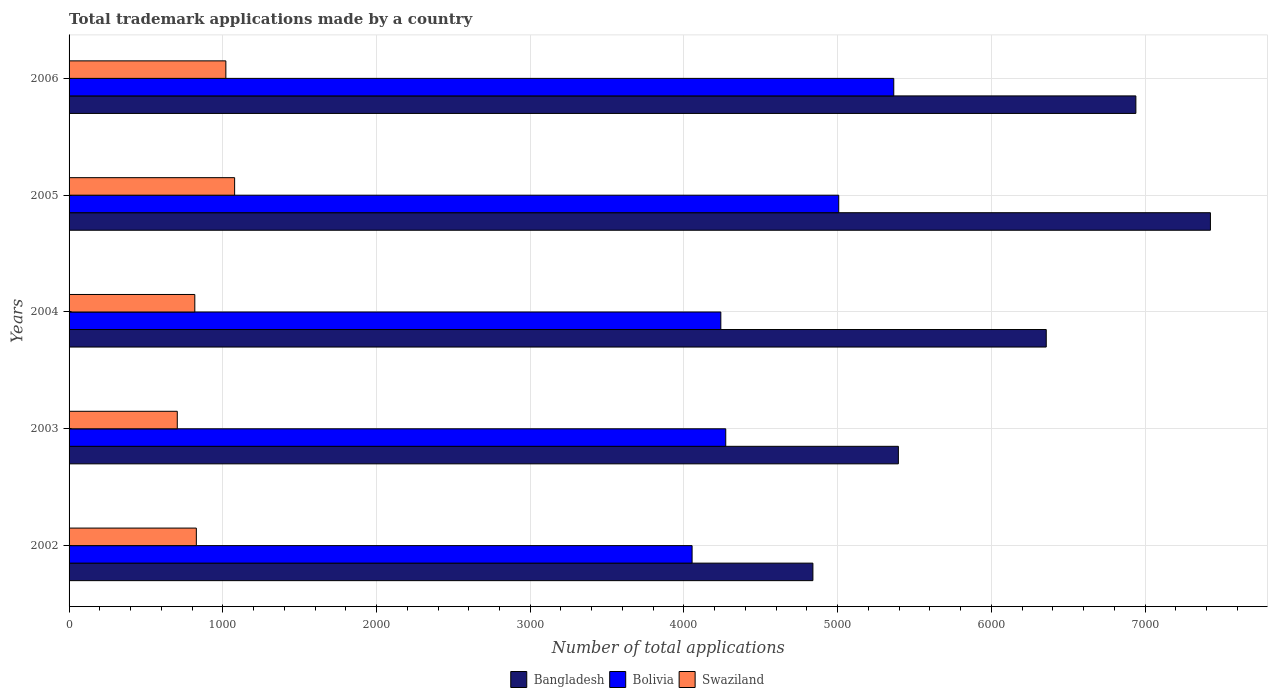How many groups of bars are there?
Keep it short and to the point. 5. Are the number of bars per tick equal to the number of legend labels?
Your answer should be very brief. Yes. Are the number of bars on each tick of the Y-axis equal?
Provide a short and direct response. Yes. How many bars are there on the 2nd tick from the top?
Provide a succinct answer. 3. What is the label of the 3rd group of bars from the top?
Keep it short and to the point. 2004. What is the number of applications made by in Bolivia in 2002?
Make the answer very short. 4053. Across all years, what is the maximum number of applications made by in Swaziland?
Your answer should be compact. 1077. Across all years, what is the minimum number of applications made by in Swaziland?
Keep it short and to the point. 704. What is the total number of applications made by in Swaziland in the graph?
Offer a terse response. 4447. What is the difference between the number of applications made by in Bolivia in 2004 and that in 2006?
Make the answer very short. -1125. What is the difference between the number of applications made by in Bangladesh in 2004 and the number of applications made by in Bolivia in 2005?
Ensure brevity in your answer.  1350. What is the average number of applications made by in Swaziland per year?
Offer a very short reply. 889.4. In the year 2002, what is the difference between the number of applications made by in Bangladesh and number of applications made by in Bolivia?
Your answer should be very brief. 786. What is the ratio of the number of applications made by in Bangladesh in 2003 to that in 2005?
Ensure brevity in your answer.  0.73. What is the difference between the highest and the second highest number of applications made by in Bolivia?
Ensure brevity in your answer.  358. What is the difference between the highest and the lowest number of applications made by in Bangladesh?
Your response must be concise. 2586. In how many years, is the number of applications made by in Swaziland greater than the average number of applications made by in Swaziland taken over all years?
Provide a succinct answer. 2. Is the sum of the number of applications made by in Bolivia in 2002 and 2006 greater than the maximum number of applications made by in Bangladesh across all years?
Your response must be concise. Yes. How many bars are there?
Your answer should be very brief. 15. What is the difference between two consecutive major ticks on the X-axis?
Your answer should be very brief. 1000. Are the values on the major ticks of X-axis written in scientific E-notation?
Your response must be concise. No. How many legend labels are there?
Make the answer very short. 3. How are the legend labels stacked?
Offer a very short reply. Horizontal. What is the title of the graph?
Provide a short and direct response. Total trademark applications made by a country. What is the label or title of the X-axis?
Give a very brief answer. Number of total applications. What is the Number of total applications of Bangladesh in 2002?
Make the answer very short. 4839. What is the Number of total applications of Bolivia in 2002?
Keep it short and to the point. 4053. What is the Number of total applications in Swaziland in 2002?
Your answer should be very brief. 828. What is the Number of total applications in Bangladesh in 2003?
Make the answer very short. 5395. What is the Number of total applications of Bolivia in 2003?
Give a very brief answer. 4272. What is the Number of total applications of Swaziland in 2003?
Your answer should be compact. 704. What is the Number of total applications in Bangladesh in 2004?
Ensure brevity in your answer.  6357. What is the Number of total applications in Bolivia in 2004?
Your answer should be very brief. 4240. What is the Number of total applications of Swaziland in 2004?
Your response must be concise. 818. What is the Number of total applications in Bangladesh in 2005?
Give a very brief answer. 7425. What is the Number of total applications of Bolivia in 2005?
Your answer should be very brief. 5007. What is the Number of total applications of Swaziland in 2005?
Your answer should be compact. 1077. What is the Number of total applications of Bangladesh in 2006?
Give a very brief answer. 6940. What is the Number of total applications in Bolivia in 2006?
Your answer should be very brief. 5365. What is the Number of total applications of Swaziland in 2006?
Provide a succinct answer. 1020. Across all years, what is the maximum Number of total applications of Bangladesh?
Offer a very short reply. 7425. Across all years, what is the maximum Number of total applications in Bolivia?
Offer a terse response. 5365. Across all years, what is the maximum Number of total applications in Swaziland?
Your answer should be compact. 1077. Across all years, what is the minimum Number of total applications of Bangladesh?
Ensure brevity in your answer.  4839. Across all years, what is the minimum Number of total applications of Bolivia?
Your answer should be very brief. 4053. Across all years, what is the minimum Number of total applications in Swaziland?
Ensure brevity in your answer.  704. What is the total Number of total applications in Bangladesh in the graph?
Keep it short and to the point. 3.10e+04. What is the total Number of total applications in Bolivia in the graph?
Offer a very short reply. 2.29e+04. What is the total Number of total applications of Swaziland in the graph?
Offer a terse response. 4447. What is the difference between the Number of total applications of Bangladesh in 2002 and that in 2003?
Make the answer very short. -556. What is the difference between the Number of total applications in Bolivia in 2002 and that in 2003?
Ensure brevity in your answer.  -219. What is the difference between the Number of total applications of Swaziland in 2002 and that in 2003?
Offer a very short reply. 124. What is the difference between the Number of total applications of Bangladesh in 2002 and that in 2004?
Your answer should be compact. -1518. What is the difference between the Number of total applications in Bolivia in 2002 and that in 2004?
Make the answer very short. -187. What is the difference between the Number of total applications of Swaziland in 2002 and that in 2004?
Keep it short and to the point. 10. What is the difference between the Number of total applications of Bangladesh in 2002 and that in 2005?
Ensure brevity in your answer.  -2586. What is the difference between the Number of total applications in Bolivia in 2002 and that in 2005?
Your answer should be compact. -954. What is the difference between the Number of total applications in Swaziland in 2002 and that in 2005?
Give a very brief answer. -249. What is the difference between the Number of total applications in Bangladesh in 2002 and that in 2006?
Ensure brevity in your answer.  -2101. What is the difference between the Number of total applications of Bolivia in 2002 and that in 2006?
Ensure brevity in your answer.  -1312. What is the difference between the Number of total applications in Swaziland in 2002 and that in 2006?
Ensure brevity in your answer.  -192. What is the difference between the Number of total applications of Bangladesh in 2003 and that in 2004?
Offer a terse response. -962. What is the difference between the Number of total applications in Swaziland in 2003 and that in 2004?
Your answer should be very brief. -114. What is the difference between the Number of total applications in Bangladesh in 2003 and that in 2005?
Make the answer very short. -2030. What is the difference between the Number of total applications in Bolivia in 2003 and that in 2005?
Provide a succinct answer. -735. What is the difference between the Number of total applications in Swaziland in 2003 and that in 2005?
Offer a terse response. -373. What is the difference between the Number of total applications in Bangladesh in 2003 and that in 2006?
Your answer should be compact. -1545. What is the difference between the Number of total applications of Bolivia in 2003 and that in 2006?
Your answer should be very brief. -1093. What is the difference between the Number of total applications of Swaziland in 2003 and that in 2006?
Your response must be concise. -316. What is the difference between the Number of total applications in Bangladesh in 2004 and that in 2005?
Keep it short and to the point. -1068. What is the difference between the Number of total applications in Bolivia in 2004 and that in 2005?
Offer a very short reply. -767. What is the difference between the Number of total applications of Swaziland in 2004 and that in 2005?
Provide a succinct answer. -259. What is the difference between the Number of total applications in Bangladesh in 2004 and that in 2006?
Your answer should be very brief. -583. What is the difference between the Number of total applications of Bolivia in 2004 and that in 2006?
Offer a very short reply. -1125. What is the difference between the Number of total applications of Swaziland in 2004 and that in 2006?
Your answer should be compact. -202. What is the difference between the Number of total applications in Bangladesh in 2005 and that in 2006?
Your answer should be very brief. 485. What is the difference between the Number of total applications in Bolivia in 2005 and that in 2006?
Provide a short and direct response. -358. What is the difference between the Number of total applications of Swaziland in 2005 and that in 2006?
Provide a short and direct response. 57. What is the difference between the Number of total applications in Bangladesh in 2002 and the Number of total applications in Bolivia in 2003?
Your answer should be very brief. 567. What is the difference between the Number of total applications of Bangladesh in 2002 and the Number of total applications of Swaziland in 2003?
Offer a very short reply. 4135. What is the difference between the Number of total applications in Bolivia in 2002 and the Number of total applications in Swaziland in 2003?
Make the answer very short. 3349. What is the difference between the Number of total applications in Bangladesh in 2002 and the Number of total applications in Bolivia in 2004?
Keep it short and to the point. 599. What is the difference between the Number of total applications in Bangladesh in 2002 and the Number of total applications in Swaziland in 2004?
Your answer should be compact. 4021. What is the difference between the Number of total applications of Bolivia in 2002 and the Number of total applications of Swaziland in 2004?
Give a very brief answer. 3235. What is the difference between the Number of total applications of Bangladesh in 2002 and the Number of total applications of Bolivia in 2005?
Your response must be concise. -168. What is the difference between the Number of total applications of Bangladesh in 2002 and the Number of total applications of Swaziland in 2005?
Make the answer very short. 3762. What is the difference between the Number of total applications in Bolivia in 2002 and the Number of total applications in Swaziland in 2005?
Provide a short and direct response. 2976. What is the difference between the Number of total applications in Bangladesh in 2002 and the Number of total applications in Bolivia in 2006?
Keep it short and to the point. -526. What is the difference between the Number of total applications of Bangladesh in 2002 and the Number of total applications of Swaziland in 2006?
Provide a succinct answer. 3819. What is the difference between the Number of total applications of Bolivia in 2002 and the Number of total applications of Swaziland in 2006?
Provide a succinct answer. 3033. What is the difference between the Number of total applications in Bangladesh in 2003 and the Number of total applications in Bolivia in 2004?
Make the answer very short. 1155. What is the difference between the Number of total applications in Bangladesh in 2003 and the Number of total applications in Swaziland in 2004?
Your response must be concise. 4577. What is the difference between the Number of total applications in Bolivia in 2003 and the Number of total applications in Swaziland in 2004?
Give a very brief answer. 3454. What is the difference between the Number of total applications of Bangladesh in 2003 and the Number of total applications of Bolivia in 2005?
Ensure brevity in your answer.  388. What is the difference between the Number of total applications in Bangladesh in 2003 and the Number of total applications in Swaziland in 2005?
Make the answer very short. 4318. What is the difference between the Number of total applications of Bolivia in 2003 and the Number of total applications of Swaziland in 2005?
Provide a short and direct response. 3195. What is the difference between the Number of total applications of Bangladesh in 2003 and the Number of total applications of Swaziland in 2006?
Your answer should be very brief. 4375. What is the difference between the Number of total applications of Bolivia in 2003 and the Number of total applications of Swaziland in 2006?
Your response must be concise. 3252. What is the difference between the Number of total applications in Bangladesh in 2004 and the Number of total applications in Bolivia in 2005?
Your response must be concise. 1350. What is the difference between the Number of total applications in Bangladesh in 2004 and the Number of total applications in Swaziland in 2005?
Provide a short and direct response. 5280. What is the difference between the Number of total applications in Bolivia in 2004 and the Number of total applications in Swaziland in 2005?
Keep it short and to the point. 3163. What is the difference between the Number of total applications in Bangladesh in 2004 and the Number of total applications in Bolivia in 2006?
Your answer should be very brief. 992. What is the difference between the Number of total applications in Bangladesh in 2004 and the Number of total applications in Swaziland in 2006?
Offer a terse response. 5337. What is the difference between the Number of total applications of Bolivia in 2004 and the Number of total applications of Swaziland in 2006?
Provide a succinct answer. 3220. What is the difference between the Number of total applications of Bangladesh in 2005 and the Number of total applications of Bolivia in 2006?
Make the answer very short. 2060. What is the difference between the Number of total applications in Bangladesh in 2005 and the Number of total applications in Swaziland in 2006?
Your answer should be very brief. 6405. What is the difference between the Number of total applications in Bolivia in 2005 and the Number of total applications in Swaziland in 2006?
Your answer should be compact. 3987. What is the average Number of total applications of Bangladesh per year?
Make the answer very short. 6191.2. What is the average Number of total applications of Bolivia per year?
Provide a succinct answer. 4587.4. What is the average Number of total applications in Swaziland per year?
Keep it short and to the point. 889.4. In the year 2002, what is the difference between the Number of total applications in Bangladesh and Number of total applications in Bolivia?
Ensure brevity in your answer.  786. In the year 2002, what is the difference between the Number of total applications in Bangladesh and Number of total applications in Swaziland?
Your response must be concise. 4011. In the year 2002, what is the difference between the Number of total applications of Bolivia and Number of total applications of Swaziland?
Provide a succinct answer. 3225. In the year 2003, what is the difference between the Number of total applications in Bangladesh and Number of total applications in Bolivia?
Provide a short and direct response. 1123. In the year 2003, what is the difference between the Number of total applications of Bangladesh and Number of total applications of Swaziland?
Offer a very short reply. 4691. In the year 2003, what is the difference between the Number of total applications of Bolivia and Number of total applications of Swaziland?
Give a very brief answer. 3568. In the year 2004, what is the difference between the Number of total applications in Bangladesh and Number of total applications in Bolivia?
Your answer should be very brief. 2117. In the year 2004, what is the difference between the Number of total applications in Bangladesh and Number of total applications in Swaziland?
Keep it short and to the point. 5539. In the year 2004, what is the difference between the Number of total applications of Bolivia and Number of total applications of Swaziland?
Ensure brevity in your answer.  3422. In the year 2005, what is the difference between the Number of total applications in Bangladesh and Number of total applications in Bolivia?
Give a very brief answer. 2418. In the year 2005, what is the difference between the Number of total applications in Bangladesh and Number of total applications in Swaziland?
Your answer should be compact. 6348. In the year 2005, what is the difference between the Number of total applications of Bolivia and Number of total applications of Swaziland?
Your answer should be compact. 3930. In the year 2006, what is the difference between the Number of total applications in Bangladesh and Number of total applications in Bolivia?
Your answer should be very brief. 1575. In the year 2006, what is the difference between the Number of total applications in Bangladesh and Number of total applications in Swaziland?
Give a very brief answer. 5920. In the year 2006, what is the difference between the Number of total applications of Bolivia and Number of total applications of Swaziland?
Your response must be concise. 4345. What is the ratio of the Number of total applications in Bangladesh in 2002 to that in 2003?
Ensure brevity in your answer.  0.9. What is the ratio of the Number of total applications of Bolivia in 2002 to that in 2003?
Offer a very short reply. 0.95. What is the ratio of the Number of total applications in Swaziland in 2002 to that in 2003?
Your response must be concise. 1.18. What is the ratio of the Number of total applications in Bangladesh in 2002 to that in 2004?
Your response must be concise. 0.76. What is the ratio of the Number of total applications of Bolivia in 2002 to that in 2004?
Offer a terse response. 0.96. What is the ratio of the Number of total applications in Swaziland in 2002 to that in 2004?
Keep it short and to the point. 1.01. What is the ratio of the Number of total applications in Bangladesh in 2002 to that in 2005?
Give a very brief answer. 0.65. What is the ratio of the Number of total applications in Bolivia in 2002 to that in 2005?
Your answer should be very brief. 0.81. What is the ratio of the Number of total applications in Swaziland in 2002 to that in 2005?
Your answer should be compact. 0.77. What is the ratio of the Number of total applications in Bangladesh in 2002 to that in 2006?
Offer a very short reply. 0.7. What is the ratio of the Number of total applications in Bolivia in 2002 to that in 2006?
Ensure brevity in your answer.  0.76. What is the ratio of the Number of total applications of Swaziland in 2002 to that in 2006?
Keep it short and to the point. 0.81. What is the ratio of the Number of total applications of Bangladesh in 2003 to that in 2004?
Keep it short and to the point. 0.85. What is the ratio of the Number of total applications of Bolivia in 2003 to that in 2004?
Keep it short and to the point. 1.01. What is the ratio of the Number of total applications of Swaziland in 2003 to that in 2004?
Make the answer very short. 0.86. What is the ratio of the Number of total applications of Bangladesh in 2003 to that in 2005?
Your response must be concise. 0.73. What is the ratio of the Number of total applications in Bolivia in 2003 to that in 2005?
Make the answer very short. 0.85. What is the ratio of the Number of total applications in Swaziland in 2003 to that in 2005?
Offer a terse response. 0.65. What is the ratio of the Number of total applications of Bangladesh in 2003 to that in 2006?
Your answer should be compact. 0.78. What is the ratio of the Number of total applications of Bolivia in 2003 to that in 2006?
Your answer should be very brief. 0.8. What is the ratio of the Number of total applications of Swaziland in 2003 to that in 2006?
Give a very brief answer. 0.69. What is the ratio of the Number of total applications of Bangladesh in 2004 to that in 2005?
Give a very brief answer. 0.86. What is the ratio of the Number of total applications in Bolivia in 2004 to that in 2005?
Make the answer very short. 0.85. What is the ratio of the Number of total applications of Swaziland in 2004 to that in 2005?
Your response must be concise. 0.76. What is the ratio of the Number of total applications in Bangladesh in 2004 to that in 2006?
Make the answer very short. 0.92. What is the ratio of the Number of total applications of Bolivia in 2004 to that in 2006?
Offer a very short reply. 0.79. What is the ratio of the Number of total applications in Swaziland in 2004 to that in 2006?
Provide a succinct answer. 0.8. What is the ratio of the Number of total applications in Bangladesh in 2005 to that in 2006?
Your answer should be very brief. 1.07. What is the ratio of the Number of total applications of Bolivia in 2005 to that in 2006?
Offer a terse response. 0.93. What is the ratio of the Number of total applications in Swaziland in 2005 to that in 2006?
Your response must be concise. 1.06. What is the difference between the highest and the second highest Number of total applications of Bangladesh?
Keep it short and to the point. 485. What is the difference between the highest and the second highest Number of total applications of Bolivia?
Your answer should be very brief. 358. What is the difference between the highest and the lowest Number of total applications in Bangladesh?
Give a very brief answer. 2586. What is the difference between the highest and the lowest Number of total applications of Bolivia?
Provide a short and direct response. 1312. What is the difference between the highest and the lowest Number of total applications of Swaziland?
Keep it short and to the point. 373. 